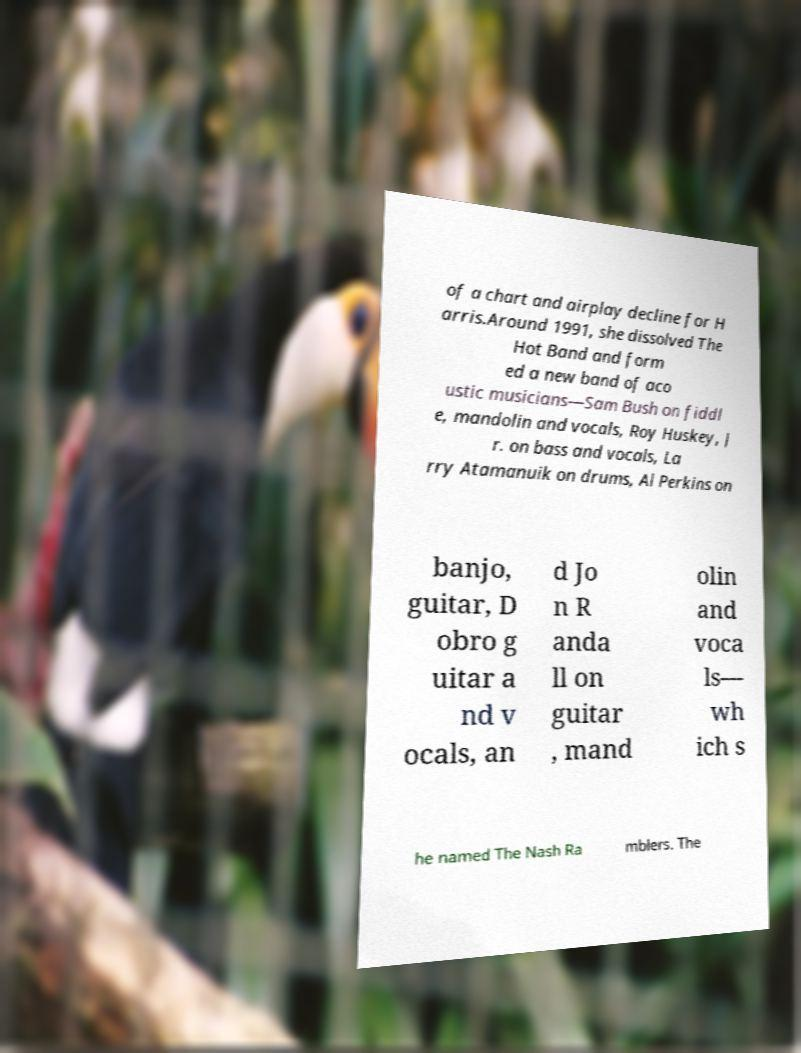Can you read and provide the text displayed in the image?This photo seems to have some interesting text. Can you extract and type it out for me? of a chart and airplay decline for H arris.Around 1991, she dissolved The Hot Band and form ed a new band of aco ustic musicians—Sam Bush on fiddl e, mandolin and vocals, Roy Huskey, J r. on bass and vocals, La rry Atamanuik on drums, Al Perkins on banjo, guitar, D obro g uitar a nd v ocals, an d Jo n R anda ll on guitar , mand olin and voca ls— wh ich s he named The Nash Ra mblers. The 